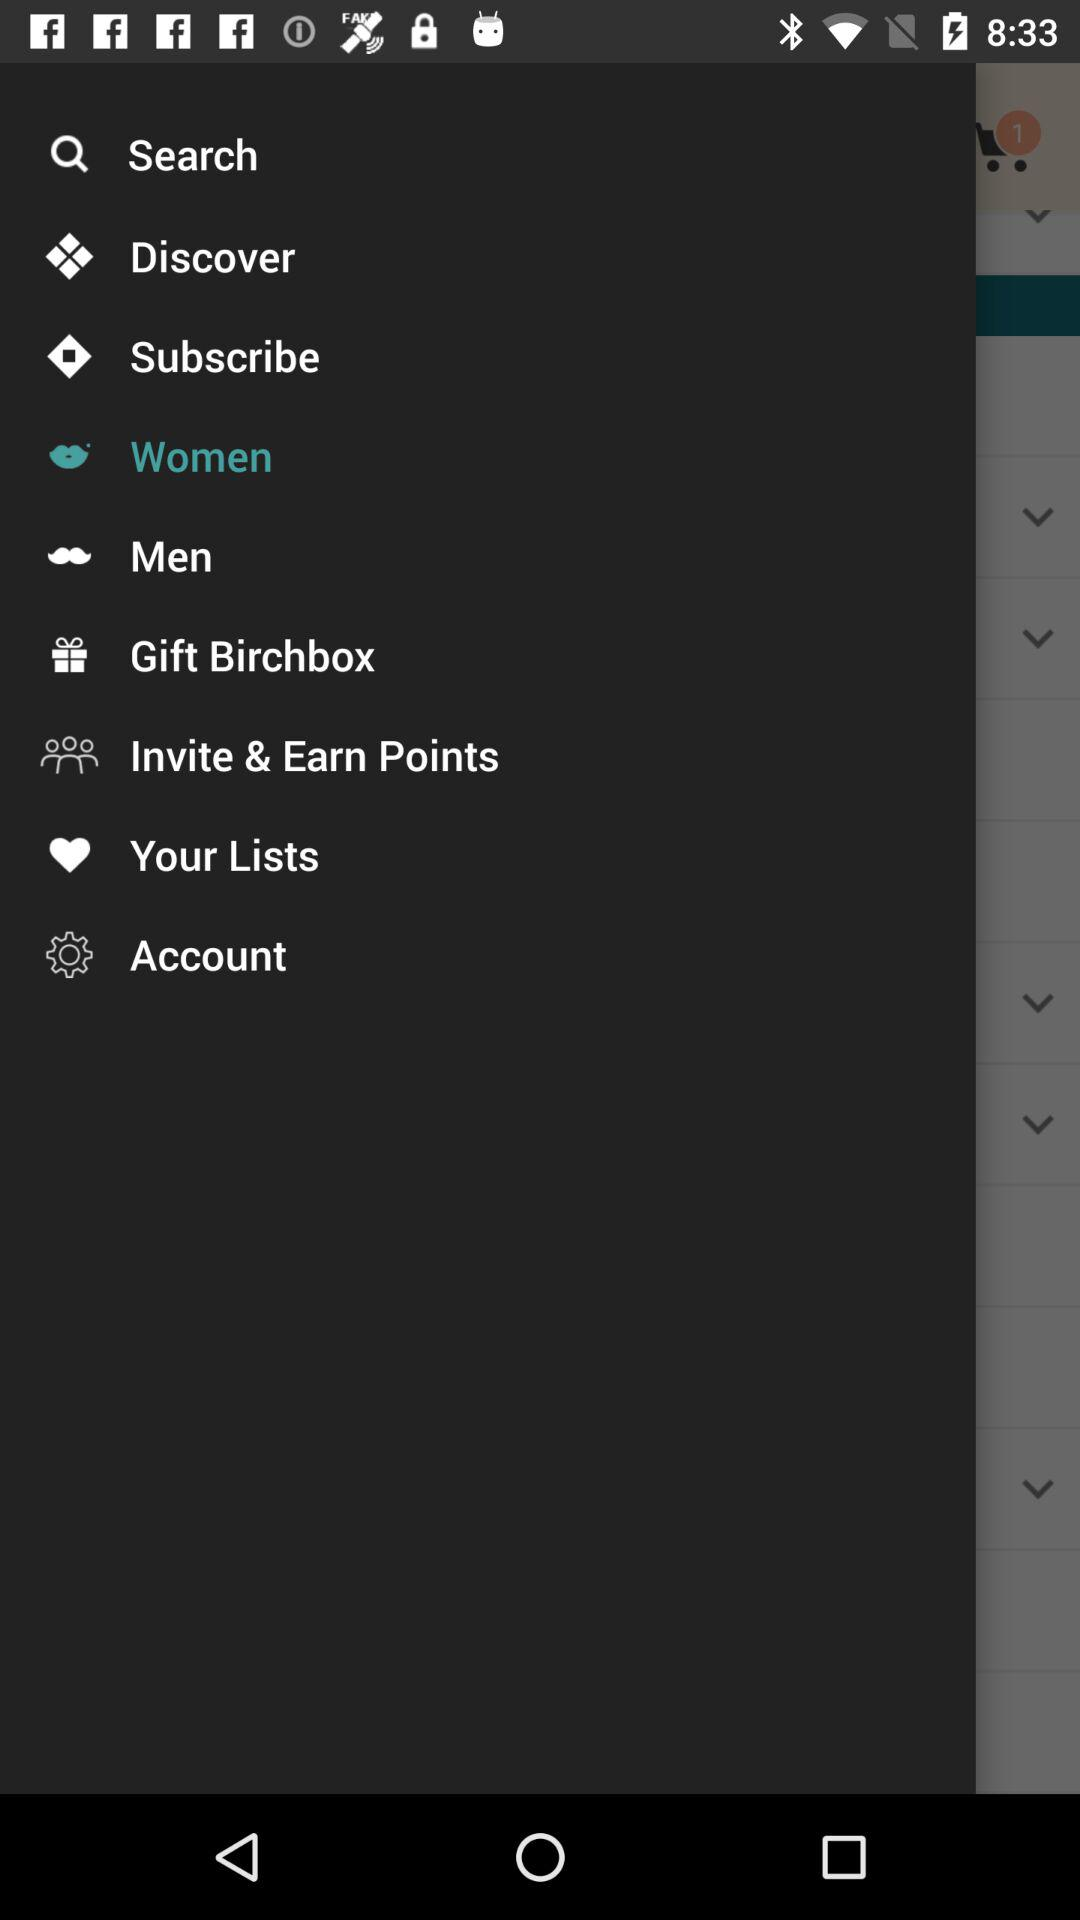Which item has been selected? The selected item is "Women". 